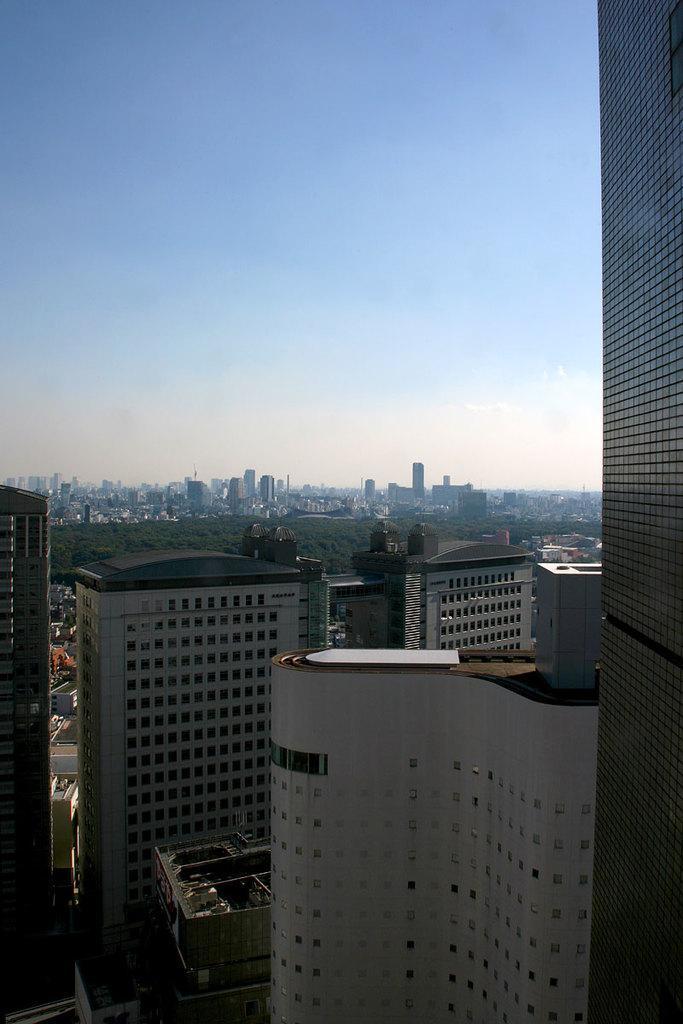Describe this image in one or two sentences. At the bottom of this image, there are buildings and mountains on the ground. In the background, there are clouds in the sky. 